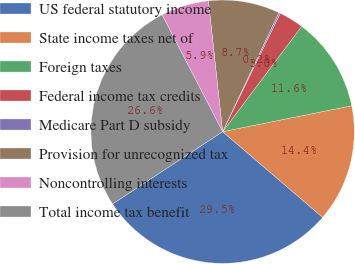Convert chart. <chart><loc_0><loc_0><loc_500><loc_500><pie_chart><fcel>US federal statutory income<fcel>State income taxes net of<fcel>Foreign taxes<fcel>Federal income tax credits<fcel>Medicare Part D subsidy<fcel>Provision for unrecognized tax<fcel>Noncontrolling interests<fcel>Total income tax benefit<nl><fcel>29.48%<fcel>14.43%<fcel>11.59%<fcel>3.04%<fcel>0.19%<fcel>8.74%<fcel>5.89%<fcel>26.63%<nl></chart> 